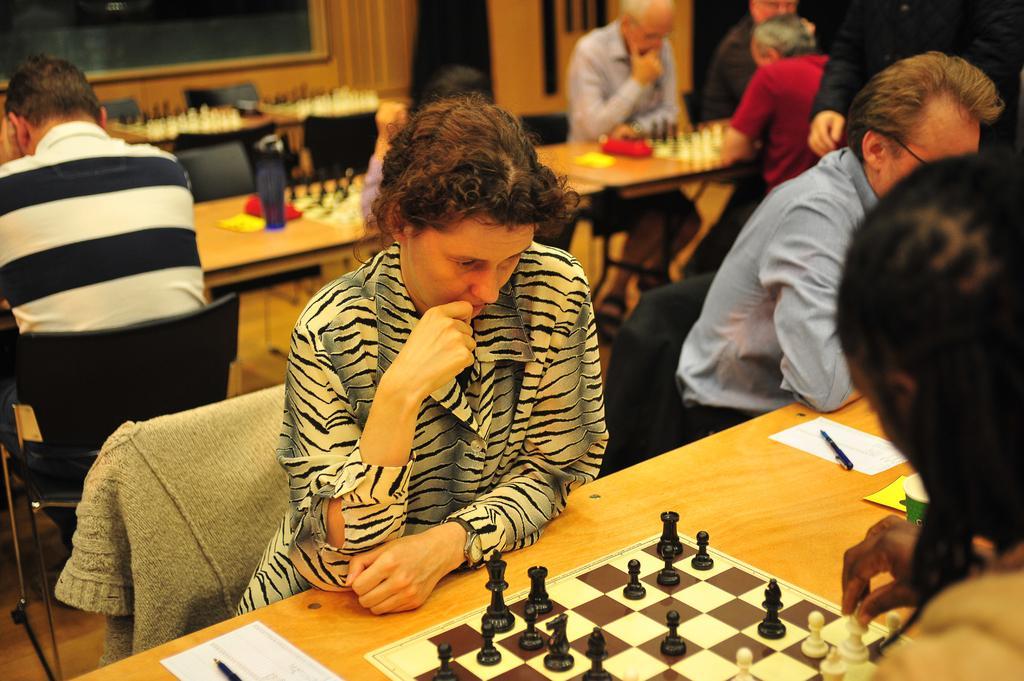Please provide a concise description of this image. In this image I see lot of people sitting on the chairs and there are tables in front of them. I can also see that on the tables there are papers, pens and chessboard with the coins. In the background I see the wall. 